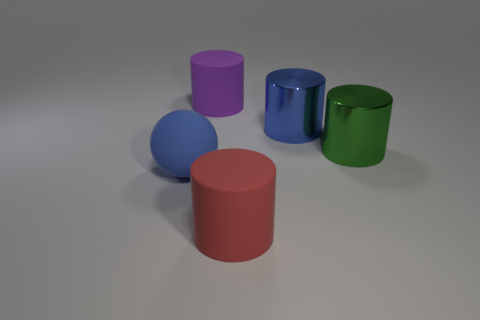Subtract all big blue cylinders. How many cylinders are left? 3 Add 2 red things. How many objects exist? 7 Subtract all purple cylinders. How many cylinders are left? 3 Subtract all cylinders. How many objects are left? 1 Subtract all yellow cylinders. Subtract all purple spheres. How many cylinders are left? 4 Add 3 brown shiny cylinders. How many brown shiny cylinders exist? 3 Subtract 0 purple cubes. How many objects are left? 5 Subtract all blue shiny cylinders. Subtract all large green cylinders. How many objects are left? 3 Add 1 purple matte cylinders. How many purple matte cylinders are left? 2 